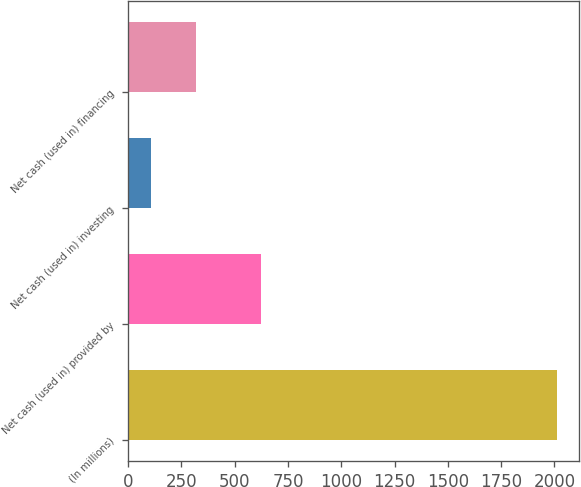Convert chart to OTSL. <chart><loc_0><loc_0><loc_500><loc_500><bar_chart><fcel>(In millions)<fcel>Net cash (used in) provided by<fcel>Net cash (used in) investing<fcel>Net cash (used in) financing<nl><fcel>2013<fcel>624.8<fcel>105.5<fcel>319.8<nl></chart> 